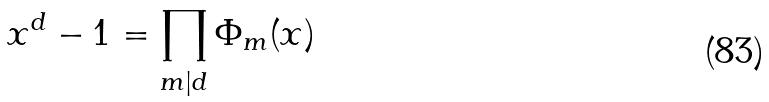Convert formula to latex. <formula><loc_0><loc_0><loc_500><loc_500>x ^ { d } - 1 = \prod _ { m | d } \Phi _ { m } ( x )</formula> 